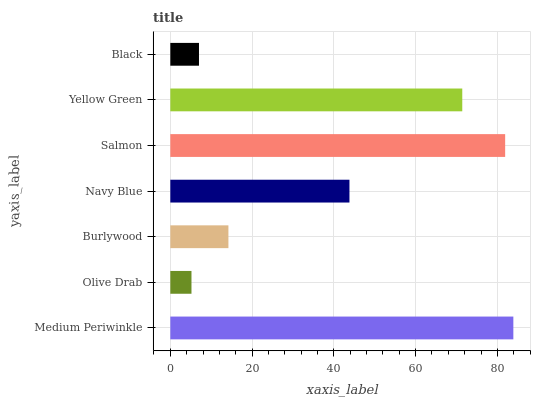Is Olive Drab the minimum?
Answer yes or no. Yes. Is Medium Periwinkle the maximum?
Answer yes or no. Yes. Is Burlywood the minimum?
Answer yes or no. No. Is Burlywood the maximum?
Answer yes or no. No. Is Burlywood greater than Olive Drab?
Answer yes or no. Yes. Is Olive Drab less than Burlywood?
Answer yes or no. Yes. Is Olive Drab greater than Burlywood?
Answer yes or no. No. Is Burlywood less than Olive Drab?
Answer yes or no. No. Is Navy Blue the high median?
Answer yes or no. Yes. Is Navy Blue the low median?
Answer yes or no. Yes. Is Olive Drab the high median?
Answer yes or no. No. Is Salmon the low median?
Answer yes or no. No. 